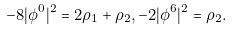Convert formula to latex. <formula><loc_0><loc_0><loc_500><loc_500>- 8 | \phi ^ { 0 } | ^ { 2 } = 2 \rho _ { 1 } + \rho _ { 2 } , - 2 | \phi ^ { 6 } | ^ { 2 } = \rho _ { 2 } .</formula> 